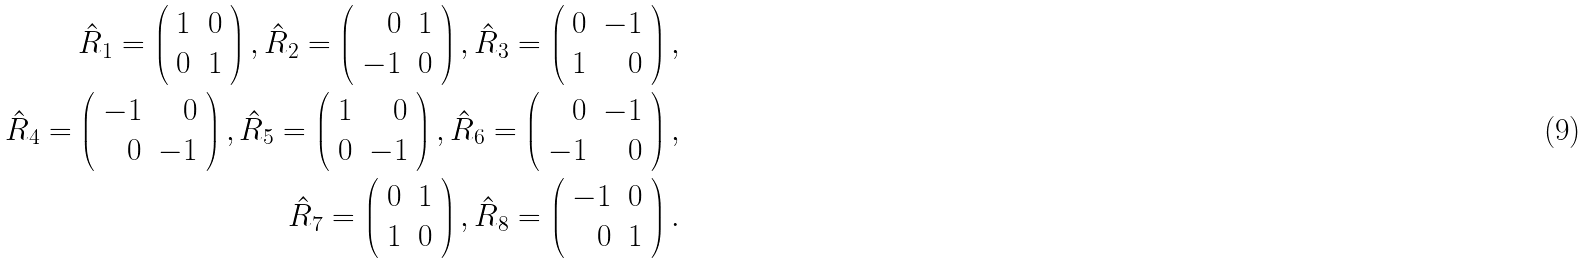Convert formula to latex. <formula><loc_0><loc_0><loc_500><loc_500>\hat { R } _ { 1 } = \left ( \begin{array} { r r } 1 & 0 \\ 0 & 1 \end{array} \right ) , \hat { R } _ { 2 } = \left ( \begin{array} { r r } 0 & 1 \\ - 1 & 0 \end{array} \right ) , \hat { R } _ { 3 } = \left ( \begin{array} { r r } 0 & - 1 \\ 1 & 0 \end{array} \right ) , \\ \hat { R } _ { 4 } = \left ( \begin{array} { r r } - 1 & 0 \\ 0 & - 1 \end{array} \right ) , \hat { R } _ { 5 } = \left ( \begin{array} { r r } 1 & 0 \\ 0 & - 1 \end{array} \right ) , \hat { R } _ { 6 } = \left ( \begin{array} { r r } 0 & - 1 \\ - 1 & 0 \end{array} \right ) , \\ \hat { R } _ { 7 } = \left ( \begin{array} { r r } 0 & 1 \\ 1 & 0 \end{array} \right ) , \hat { R } _ { 8 } = \left ( \begin{array} { r r } - 1 & 0 \\ 0 & 1 \end{array} \right ) .</formula> 